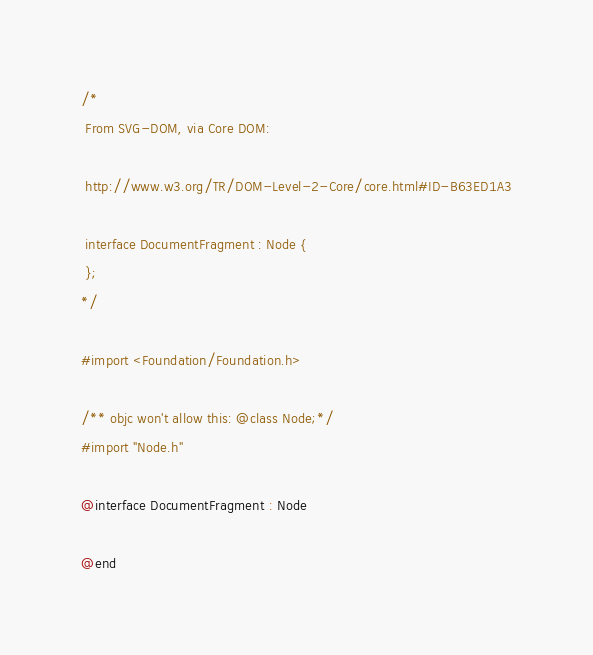Convert code to text. <code><loc_0><loc_0><loc_500><loc_500><_C_>/*
 From SVG-DOM, via Core DOM:
 
 http://www.w3.org/TR/DOM-Level-2-Core/core.html#ID-B63ED1A3
 
 interface DocumentFragment : Node {
 };
*/

#import <Foundation/Foundation.h>

/** objc won't allow this: @class Node;*/
#import "Node.h"

@interface DocumentFragment : Node

@end
</code> 